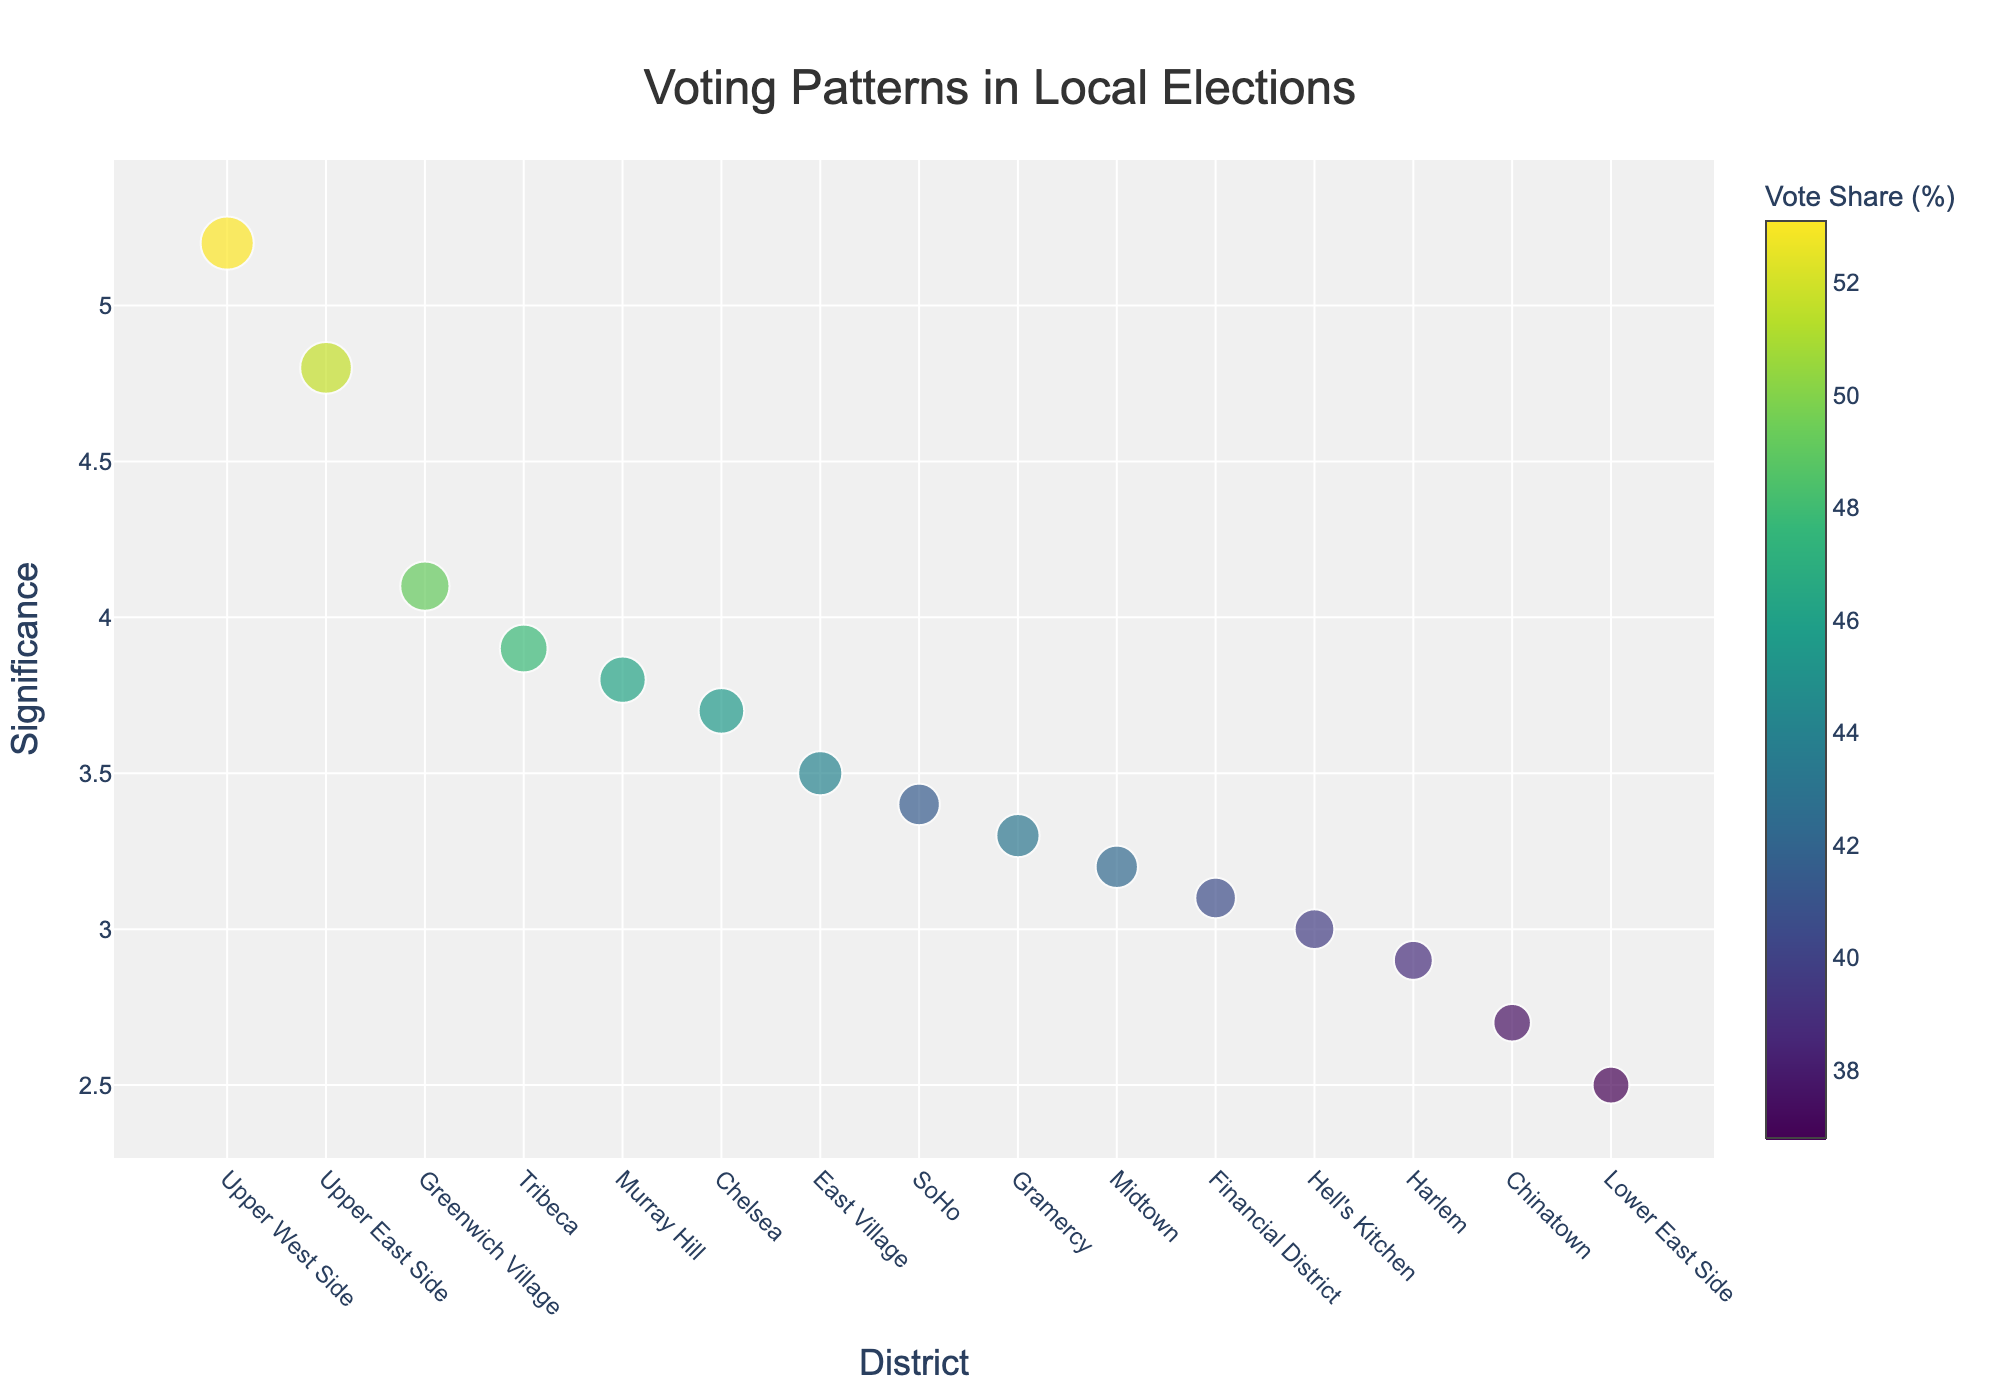Which district has the highest significance? To find the district with the highest significance, look at the y-axis and identify the tallest marker.
Answer: Upper West Side What is the title of the plot? The plot's title is displayed prominently at the top, centered and in a larger font.
Answer: Voting Patterns in Local Elections How is the candidate's vote share represented in the plot? The vote share is represented by the color and size of the markers. The color intensity and the size of the markers change with the vote share.
Answer: By color and size of markers Which candidate has the largest vote share? Look for the marker with the largest size and the warmest color, which is also typically explained in the hover text when looking at the data pointers in the plot.
Answer: Lisa Thompson Which district has a candidate with significance below 3? Significance can be identified by the y-axis values. Look for markers plotted below the value of 3 on the y-axis.
Answer: Harlem What is the significance value for Chelsea? Hovering over Chelsea's marker you'd see the hover text revealing the corresponding significance.
Answer: 3.7 Which district shows a candidate with a vote share around 44%? Find the marker size and the color that corresponds to approximately 44% as indicated by the color bar. Additionally, look for corresponding hover text values.
Answer: East Village Compare the vote shares of SoHo and Gramercy. Which one is higher? Compare the marker sizes of SoHo and Gramercy; the larger marker represents a higher vote share. You can also check the color intensity.
Answer: SoHo What is the main trend of significance values across districts? Observe the pattern of marker heights across the x-axis (Districts). The trend shows how significance changes among different districts.
Answer: Highly varied, with Upper West Side being the highest Which district has the lowest vote share? Look for the smallest marker and the least intense color. Hover over the marker to verify.
Answer: Lower East Side 